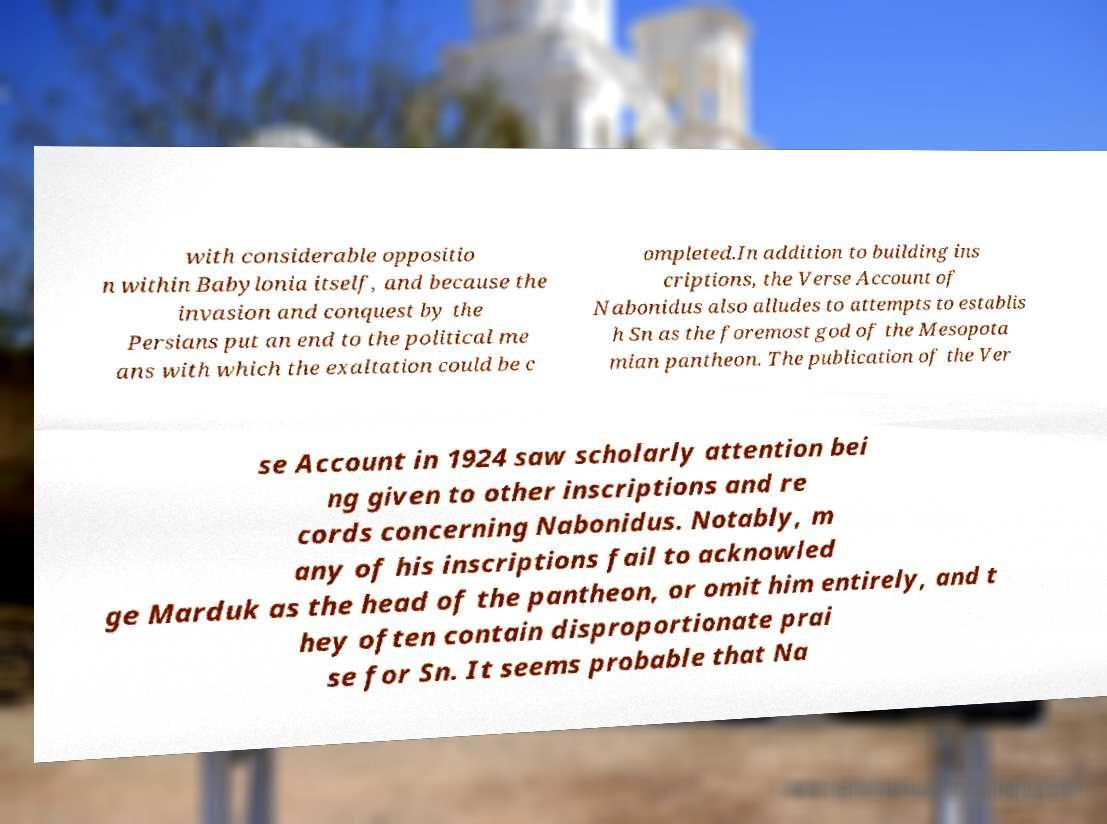I need the written content from this picture converted into text. Can you do that? with considerable oppositio n within Babylonia itself, and because the invasion and conquest by the Persians put an end to the political me ans with which the exaltation could be c ompleted.In addition to building ins criptions, the Verse Account of Nabonidus also alludes to attempts to establis h Sn as the foremost god of the Mesopota mian pantheon. The publication of the Ver se Account in 1924 saw scholarly attention bei ng given to other inscriptions and re cords concerning Nabonidus. Notably, m any of his inscriptions fail to acknowled ge Marduk as the head of the pantheon, or omit him entirely, and t hey often contain disproportionate prai se for Sn. It seems probable that Na 